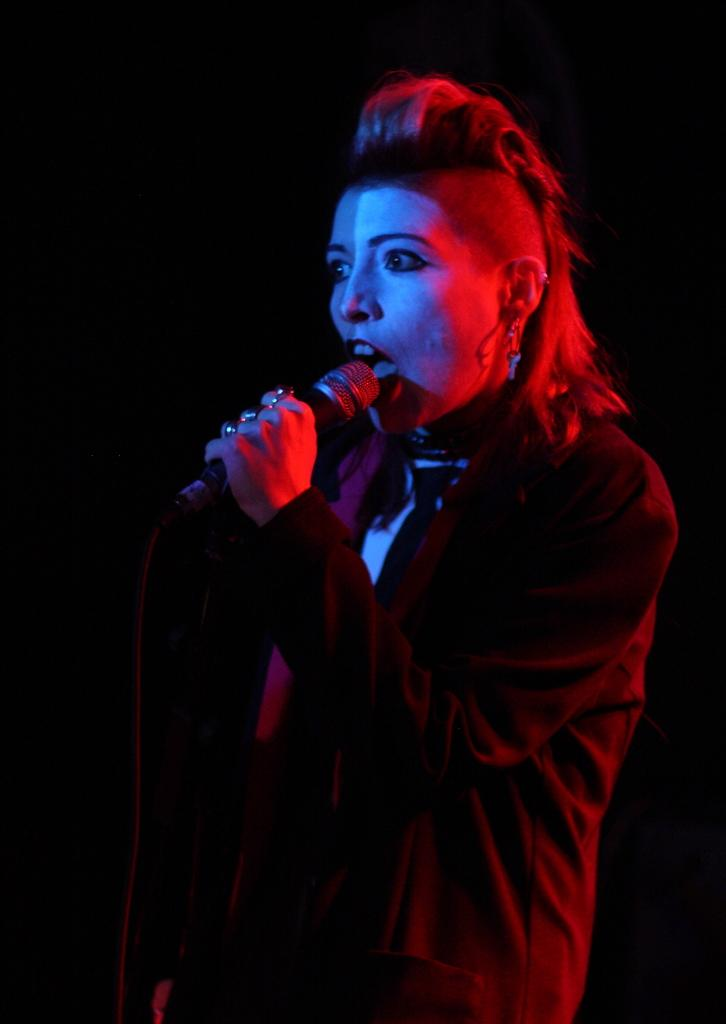What is the main subject in the foreground of the image? There is a person in the foreground of the image. What is the person holding in the image? The person is holding a mic. Can you describe any additional features of the person? Yes, there is a red light on the person. What is the color of the background in the image? The background of the image is dark. What type of jar is visible on the person's head in the image? There is no jar visible on the person's head in the image. What reward is the person receiving for holding the mic in the image? There is no reward mentioned or visible in the image; the person is simply holding a mic. 